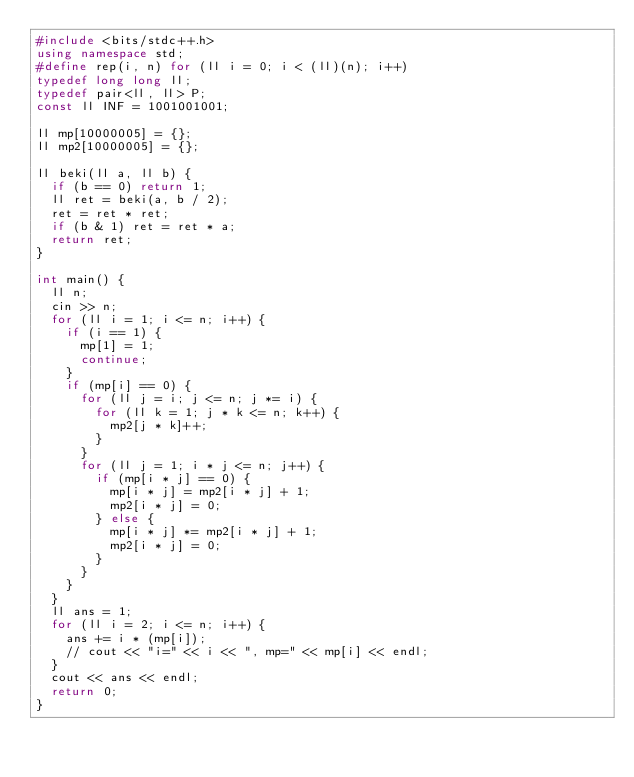<code> <loc_0><loc_0><loc_500><loc_500><_C++_>#include <bits/stdc++.h>
using namespace std;
#define rep(i, n) for (ll i = 0; i < (ll)(n); i++)
typedef long long ll;
typedef pair<ll, ll> P;
const ll INF = 1001001001;

ll mp[10000005] = {};
ll mp2[10000005] = {};

ll beki(ll a, ll b) {
  if (b == 0) return 1;
  ll ret = beki(a, b / 2);
  ret = ret * ret;
  if (b & 1) ret = ret * a;
  return ret;
}

int main() {
  ll n;
  cin >> n;
  for (ll i = 1; i <= n; i++) {
    if (i == 1) {
      mp[1] = 1;
      continue;
    }
    if (mp[i] == 0) {
      for (ll j = i; j <= n; j *= i) {
        for (ll k = 1; j * k <= n; k++) {
          mp2[j * k]++;
        }
      }
      for (ll j = 1; i * j <= n; j++) {
        if (mp[i * j] == 0) {
          mp[i * j] = mp2[i * j] + 1;
          mp2[i * j] = 0;
        } else {
          mp[i * j] *= mp2[i * j] + 1;
          mp2[i * j] = 0;
        }
      }
    }
  }
  ll ans = 1;
  for (ll i = 2; i <= n; i++) {
    ans += i * (mp[i]);
    // cout << "i=" << i << ", mp=" << mp[i] << endl;
  }
  cout << ans << endl;
  return 0;
}</code> 